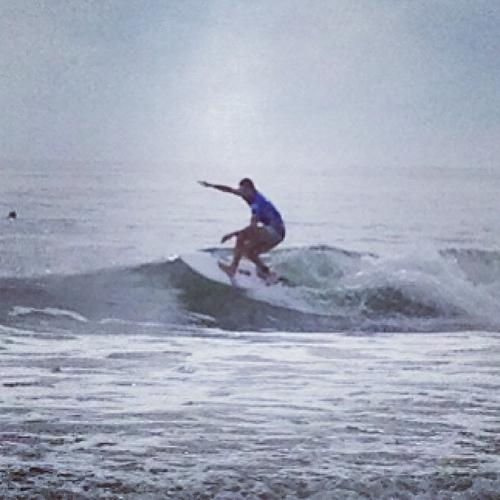Write a brief description of the weather conditions in the image. The image shows a clear, blue sky with white clouds scattered throughout. Discuss the appearance of the ocean in the image. The ocean has small waves and ripples in the tide, with some white and choppy water around the surfboard. Describe the color and appearance of the sky in the image. The sky is blue with a slight haze, and it features white clouds in various sizes scattered throughout. What type of clothing is the surfer wearing in the image? The surfer is wearing a blue shirt and grey shorts. In terms of image quality, how would you rate this image? Justify your answer. I would rate the image quality as good, considering the clear depiction of the various objects, such as the surfer, ocean, and sky elements. Can you identify any individuals in the water besides the surfer? If so, describe their appearance. There is a person swimming in the water, only their head is visible, sticking out of the water. Discuss the interaction between the surfer and the water in the image. The surfer is riding a small wave while maintaining balance on the surfboard. The surfboard creates some waves and white water. How many legs and arms can be seen in the image? In the image, two legs and two arms can be seen. What emotions might the image evoke? The image might evoke excitement, adventure, relaxation, and a sense of freedom. What is the primary activity depicted in this image? The primary activity in this image is a man surfing on a surfboard in the ocean. 